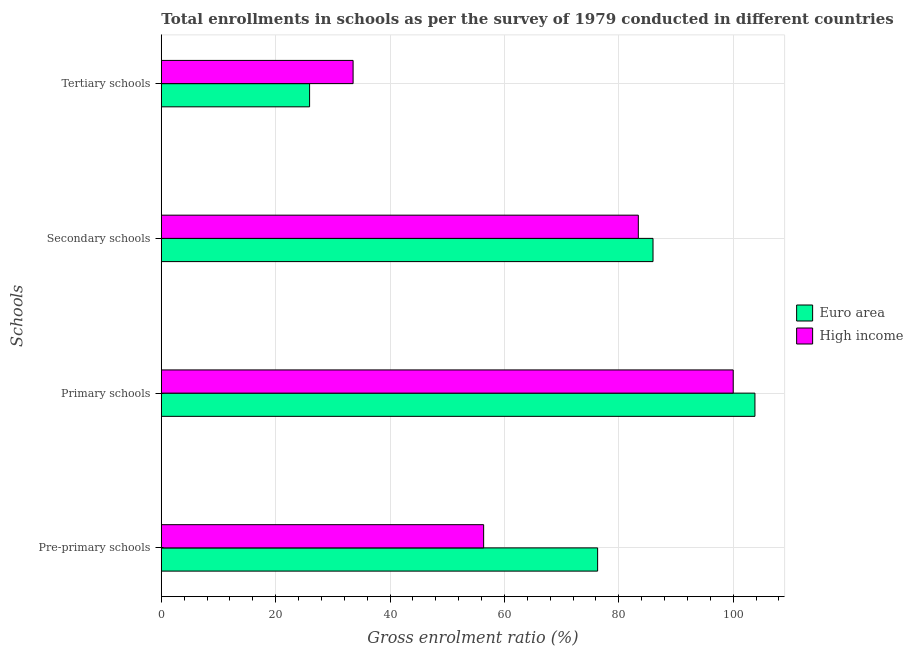How many different coloured bars are there?
Offer a very short reply. 2. How many groups of bars are there?
Make the answer very short. 4. Are the number of bars per tick equal to the number of legend labels?
Make the answer very short. Yes. How many bars are there on the 1st tick from the top?
Offer a terse response. 2. What is the label of the 2nd group of bars from the top?
Ensure brevity in your answer.  Secondary schools. What is the gross enrolment ratio in pre-primary schools in High income?
Keep it short and to the point. 56.36. Across all countries, what is the maximum gross enrolment ratio in secondary schools?
Provide a succinct answer. 85.98. Across all countries, what is the minimum gross enrolment ratio in tertiary schools?
Keep it short and to the point. 25.93. In which country was the gross enrolment ratio in tertiary schools minimum?
Ensure brevity in your answer.  Euro area. What is the total gross enrolment ratio in pre-primary schools in the graph?
Offer a very short reply. 132.66. What is the difference between the gross enrolment ratio in tertiary schools in Euro area and that in High income?
Ensure brevity in your answer.  -7.61. What is the difference between the gross enrolment ratio in secondary schools in Euro area and the gross enrolment ratio in pre-primary schools in High income?
Ensure brevity in your answer.  29.62. What is the average gross enrolment ratio in secondary schools per country?
Ensure brevity in your answer.  84.7. What is the difference between the gross enrolment ratio in tertiary schools and gross enrolment ratio in primary schools in High income?
Ensure brevity in your answer.  -66.47. What is the ratio of the gross enrolment ratio in primary schools in Euro area to that in High income?
Provide a succinct answer. 1.04. Is the gross enrolment ratio in tertiary schools in High income less than that in Euro area?
Offer a very short reply. No. Is the difference between the gross enrolment ratio in pre-primary schools in Euro area and High income greater than the difference between the gross enrolment ratio in primary schools in Euro area and High income?
Provide a succinct answer. Yes. What is the difference between the highest and the second highest gross enrolment ratio in primary schools?
Ensure brevity in your answer.  3.8. What is the difference between the highest and the lowest gross enrolment ratio in secondary schools?
Ensure brevity in your answer.  2.57. Is the sum of the gross enrolment ratio in primary schools in High income and Euro area greater than the maximum gross enrolment ratio in tertiary schools across all countries?
Give a very brief answer. Yes. Is it the case that in every country, the sum of the gross enrolment ratio in tertiary schools and gross enrolment ratio in secondary schools is greater than the sum of gross enrolment ratio in pre-primary schools and gross enrolment ratio in primary schools?
Your response must be concise. No. Is it the case that in every country, the sum of the gross enrolment ratio in pre-primary schools and gross enrolment ratio in primary schools is greater than the gross enrolment ratio in secondary schools?
Make the answer very short. Yes. How many bars are there?
Your answer should be very brief. 8. Are all the bars in the graph horizontal?
Offer a terse response. Yes. How many countries are there in the graph?
Provide a succinct answer. 2. What is the difference between two consecutive major ticks on the X-axis?
Provide a succinct answer. 20. Are the values on the major ticks of X-axis written in scientific E-notation?
Provide a short and direct response. No. How many legend labels are there?
Make the answer very short. 2. What is the title of the graph?
Provide a succinct answer. Total enrollments in schools as per the survey of 1979 conducted in different countries. What is the label or title of the Y-axis?
Offer a terse response. Schools. What is the Gross enrolment ratio (%) of Euro area in Pre-primary schools?
Provide a short and direct response. 76.29. What is the Gross enrolment ratio (%) of High income in Pre-primary schools?
Provide a short and direct response. 56.36. What is the Gross enrolment ratio (%) of Euro area in Primary schools?
Give a very brief answer. 103.8. What is the Gross enrolment ratio (%) of High income in Primary schools?
Your answer should be very brief. 100.01. What is the Gross enrolment ratio (%) of Euro area in Secondary schools?
Provide a short and direct response. 85.98. What is the Gross enrolment ratio (%) in High income in Secondary schools?
Provide a short and direct response. 83.41. What is the Gross enrolment ratio (%) of Euro area in Tertiary schools?
Offer a very short reply. 25.93. What is the Gross enrolment ratio (%) in High income in Tertiary schools?
Make the answer very short. 33.54. Across all Schools, what is the maximum Gross enrolment ratio (%) in Euro area?
Your response must be concise. 103.8. Across all Schools, what is the maximum Gross enrolment ratio (%) of High income?
Ensure brevity in your answer.  100.01. Across all Schools, what is the minimum Gross enrolment ratio (%) of Euro area?
Give a very brief answer. 25.93. Across all Schools, what is the minimum Gross enrolment ratio (%) in High income?
Your answer should be very brief. 33.54. What is the total Gross enrolment ratio (%) of Euro area in the graph?
Your answer should be compact. 292.01. What is the total Gross enrolment ratio (%) of High income in the graph?
Give a very brief answer. 273.32. What is the difference between the Gross enrolment ratio (%) in Euro area in Pre-primary schools and that in Primary schools?
Your answer should be very brief. -27.51. What is the difference between the Gross enrolment ratio (%) of High income in Pre-primary schools and that in Primary schools?
Your response must be concise. -43.64. What is the difference between the Gross enrolment ratio (%) of Euro area in Pre-primary schools and that in Secondary schools?
Provide a succinct answer. -9.69. What is the difference between the Gross enrolment ratio (%) of High income in Pre-primary schools and that in Secondary schools?
Ensure brevity in your answer.  -27.05. What is the difference between the Gross enrolment ratio (%) in Euro area in Pre-primary schools and that in Tertiary schools?
Ensure brevity in your answer.  50.36. What is the difference between the Gross enrolment ratio (%) of High income in Pre-primary schools and that in Tertiary schools?
Give a very brief answer. 22.83. What is the difference between the Gross enrolment ratio (%) of Euro area in Primary schools and that in Secondary schools?
Your answer should be compact. 17.82. What is the difference between the Gross enrolment ratio (%) in High income in Primary schools and that in Secondary schools?
Offer a very short reply. 16.59. What is the difference between the Gross enrolment ratio (%) in Euro area in Primary schools and that in Tertiary schools?
Offer a very short reply. 77.87. What is the difference between the Gross enrolment ratio (%) of High income in Primary schools and that in Tertiary schools?
Your response must be concise. 66.47. What is the difference between the Gross enrolment ratio (%) of Euro area in Secondary schools and that in Tertiary schools?
Offer a very short reply. 60.05. What is the difference between the Gross enrolment ratio (%) of High income in Secondary schools and that in Tertiary schools?
Provide a short and direct response. 49.88. What is the difference between the Gross enrolment ratio (%) in Euro area in Pre-primary schools and the Gross enrolment ratio (%) in High income in Primary schools?
Give a very brief answer. -23.71. What is the difference between the Gross enrolment ratio (%) of Euro area in Pre-primary schools and the Gross enrolment ratio (%) of High income in Secondary schools?
Keep it short and to the point. -7.12. What is the difference between the Gross enrolment ratio (%) in Euro area in Pre-primary schools and the Gross enrolment ratio (%) in High income in Tertiary schools?
Offer a terse response. 42.76. What is the difference between the Gross enrolment ratio (%) in Euro area in Primary schools and the Gross enrolment ratio (%) in High income in Secondary schools?
Give a very brief answer. 20.39. What is the difference between the Gross enrolment ratio (%) of Euro area in Primary schools and the Gross enrolment ratio (%) of High income in Tertiary schools?
Your answer should be compact. 70.27. What is the difference between the Gross enrolment ratio (%) in Euro area in Secondary schools and the Gross enrolment ratio (%) in High income in Tertiary schools?
Your response must be concise. 52.45. What is the average Gross enrolment ratio (%) in Euro area per Schools?
Your response must be concise. 73. What is the average Gross enrolment ratio (%) in High income per Schools?
Make the answer very short. 68.33. What is the difference between the Gross enrolment ratio (%) in Euro area and Gross enrolment ratio (%) in High income in Pre-primary schools?
Make the answer very short. 19.93. What is the difference between the Gross enrolment ratio (%) of Euro area and Gross enrolment ratio (%) of High income in Primary schools?
Keep it short and to the point. 3.8. What is the difference between the Gross enrolment ratio (%) in Euro area and Gross enrolment ratio (%) in High income in Secondary schools?
Provide a succinct answer. 2.57. What is the difference between the Gross enrolment ratio (%) in Euro area and Gross enrolment ratio (%) in High income in Tertiary schools?
Provide a succinct answer. -7.61. What is the ratio of the Gross enrolment ratio (%) of Euro area in Pre-primary schools to that in Primary schools?
Provide a succinct answer. 0.73. What is the ratio of the Gross enrolment ratio (%) of High income in Pre-primary schools to that in Primary schools?
Offer a very short reply. 0.56. What is the ratio of the Gross enrolment ratio (%) of Euro area in Pre-primary schools to that in Secondary schools?
Your response must be concise. 0.89. What is the ratio of the Gross enrolment ratio (%) in High income in Pre-primary schools to that in Secondary schools?
Ensure brevity in your answer.  0.68. What is the ratio of the Gross enrolment ratio (%) in Euro area in Pre-primary schools to that in Tertiary schools?
Your answer should be very brief. 2.94. What is the ratio of the Gross enrolment ratio (%) of High income in Pre-primary schools to that in Tertiary schools?
Provide a short and direct response. 1.68. What is the ratio of the Gross enrolment ratio (%) in Euro area in Primary schools to that in Secondary schools?
Ensure brevity in your answer.  1.21. What is the ratio of the Gross enrolment ratio (%) in High income in Primary schools to that in Secondary schools?
Make the answer very short. 1.2. What is the ratio of the Gross enrolment ratio (%) of Euro area in Primary schools to that in Tertiary schools?
Your answer should be very brief. 4. What is the ratio of the Gross enrolment ratio (%) in High income in Primary schools to that in Tertiary schools?
Ensure brevity in your answer.  2.98. What is the ratio of the Gross enrolment ratio (%) in Euro area in Secondary schools to that in Tertiary schools?
Offer a very short reply. 3.32. What is the ratio of the Gross enrolment ratio (%) of High income in Secondary schools to that in Tertiary schools?
Give a very brief answer. 2.49. What is the difference between the highest and the second highest Gross enrolment ratio (%) in Euro area?
Your response must be concise. 17.82. What is the difference between the highest and the second highest Gross enrolment ratio (%) in High income?
Offer a terse response. 16.59. What is the difference between the highest and the lowest Gross enrolment ratio (%) in Euro area?
Ensure brevity in your answer.  77.87. What is the difference between the highest and the lowest Gross enrolment ratio (%) of High income?
Offer a very short reply. 66.47. 